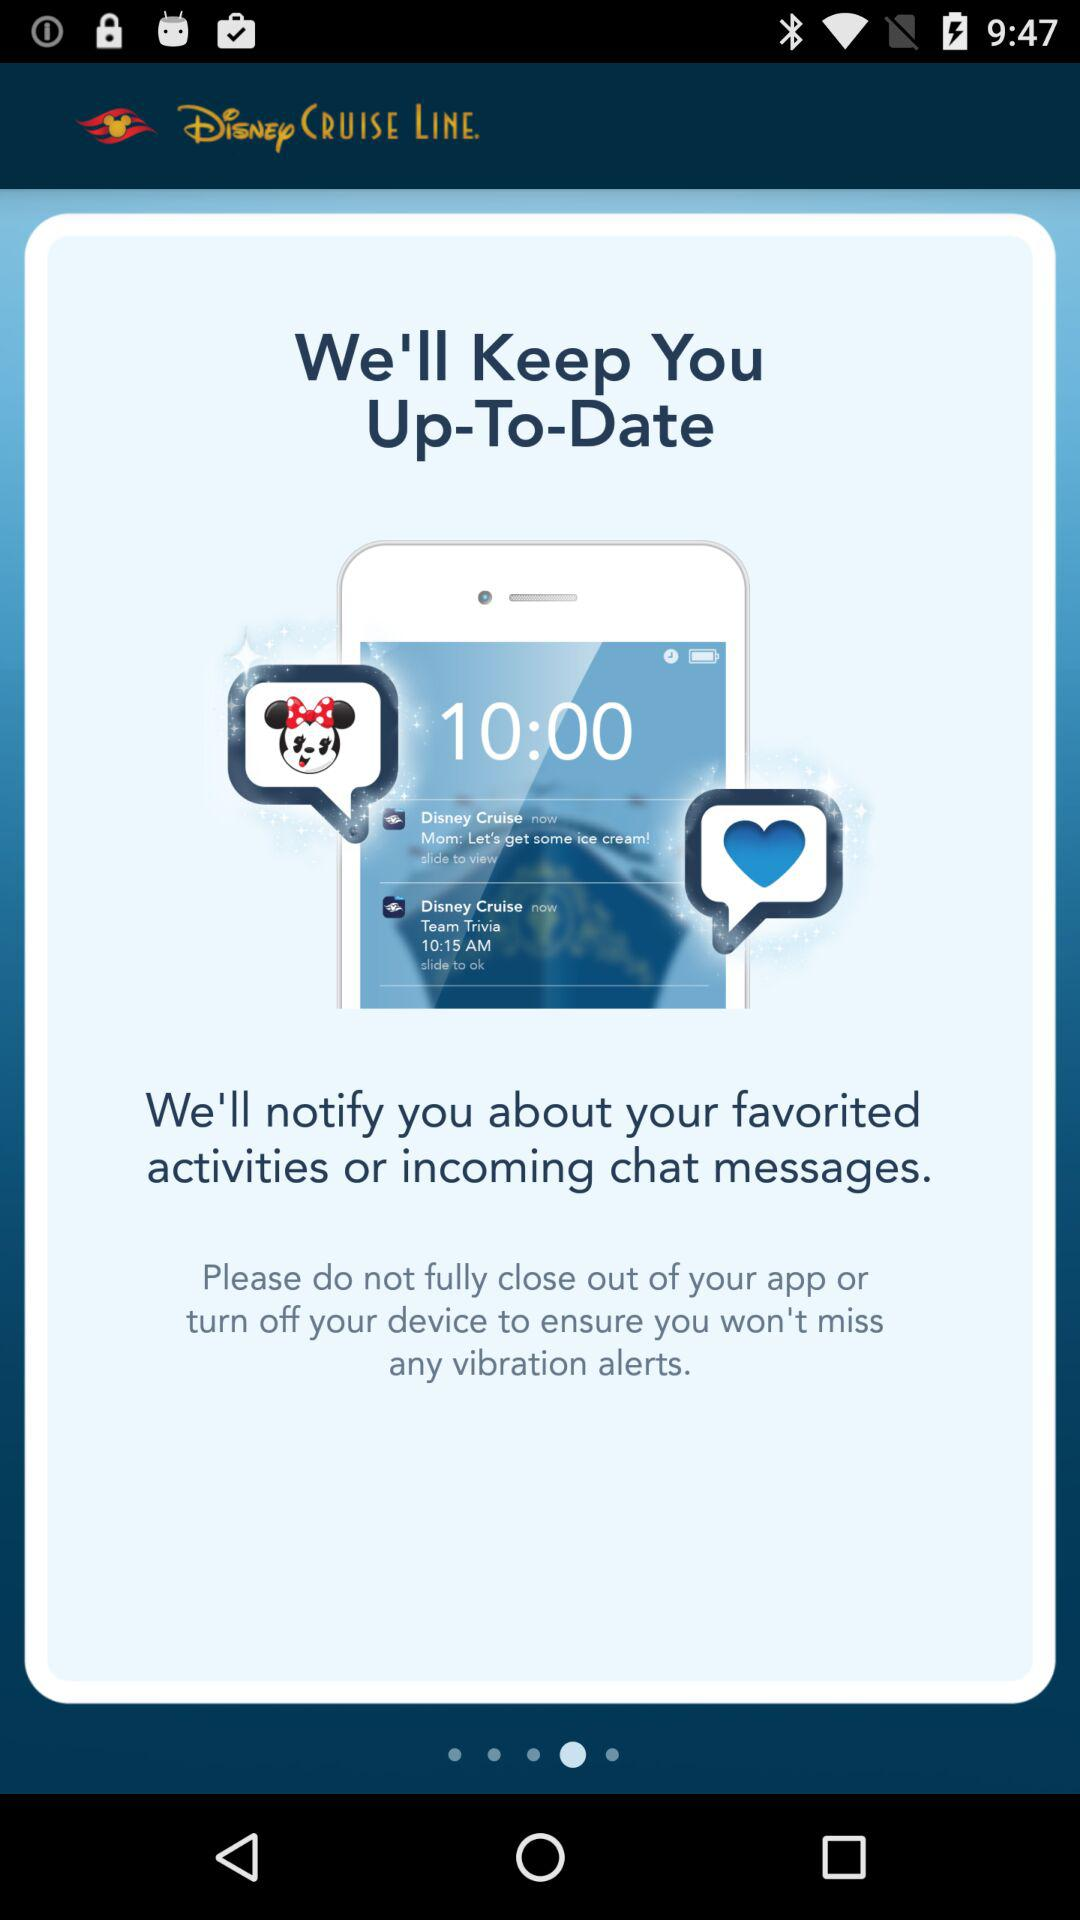What is the time mentioned below "Team Trivia"? The mentioned time below "Team Trivia" is 10:15 AM. 